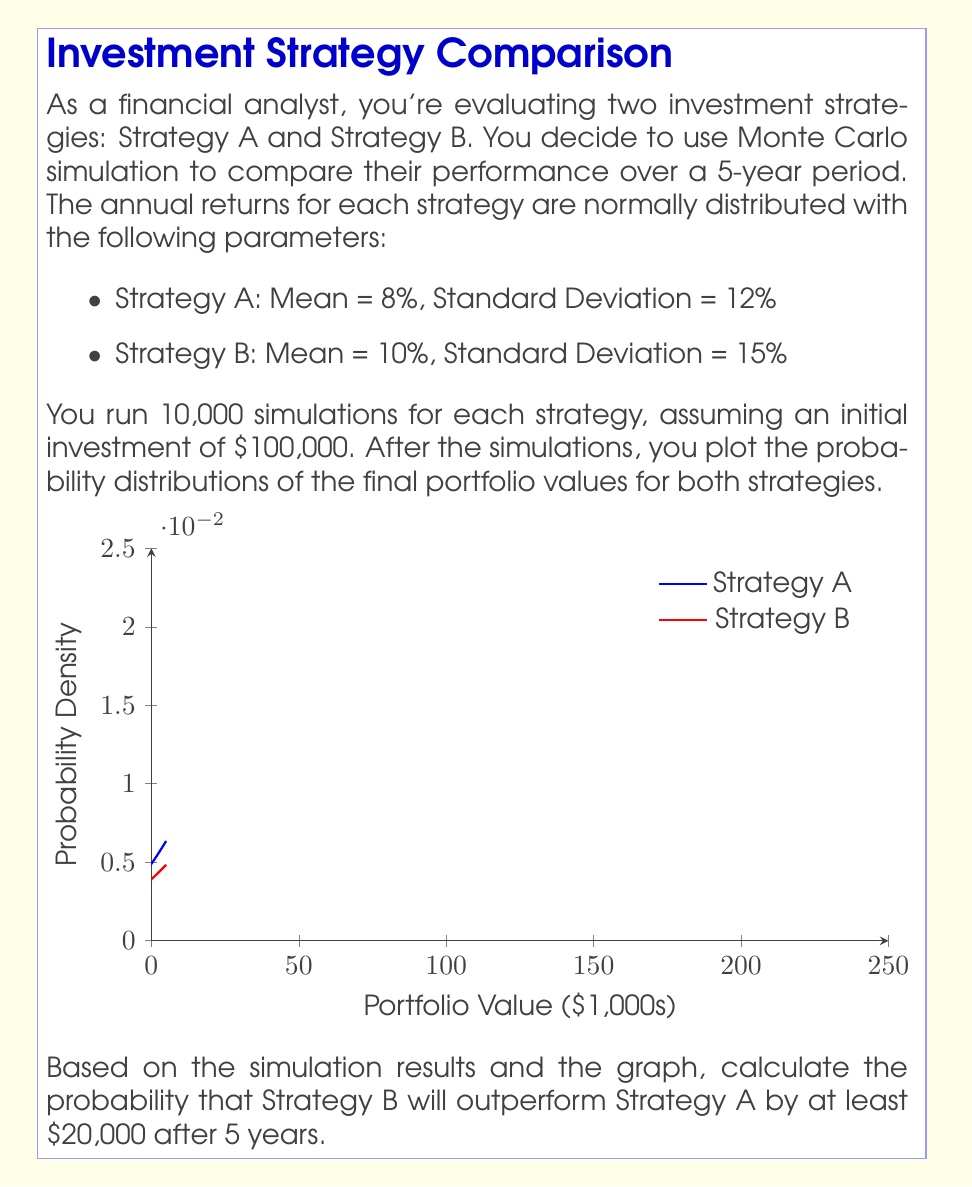Can you answer this question? To solve this problem, we need to follow these steps:

1) First, let's calculate the mean and standard deviation of the 5-year returns for each strategy:

   Strategy A:
   Mean (μA) = 8% * 5 = 40%
   Standard Deviation (σA) = 12% * √5 ≈ 26.83%

   Strategy B:
   Mean (μB) = 10% * 5 = 50%
   Standard Deviation (σB) = 15% * √5 ≈ 33.54%

2) The initial investment is $100,000, so we need to convert these percentages to dollar amounts:

   Strategy A:
   Mean (μA) = $100,000 * (1 + 40%) = $140,000
   Standard Deviation (σA) = $100,000 * 26.83% = $26,830

   Strategy B:
   Mean (μB) = $100,000 * (1 + 50%) = $150,000
   Standard Deviation (σB) = $100,000 * 33.54% = $33,540

3) We want to find the probability that B outperforms A by at least $20,000. This is equivalent to finding P(B - A > 20000).

4) The difference between two normally distributed variables is also normally distributed. The mean and standard deviation of this difference are:

   μ(B-A) = μB - μA = $150,000 - $140,000 = $10,000
   σ(B-A) = √(σB² + σA²) = √($33,540² + $26,830²) ≈ $42,953

5) Now we can standardize our question to a z-score:

   z = (x - μ) / σ = ($20,000 - $10,000) / $42,953 ≈ 0.2328

6) We want the probability of being above this z-score. Using a standard normal table or calculator, we find:

   P(Z > 0.2328) ≈ 0.4080

Therefore, the probability that Strategy B will outperform Strategy A by at least $20,000 after 5 years is approximately 0.4080 or 40.80%.
Answer: 0.4080 or 40.80% 